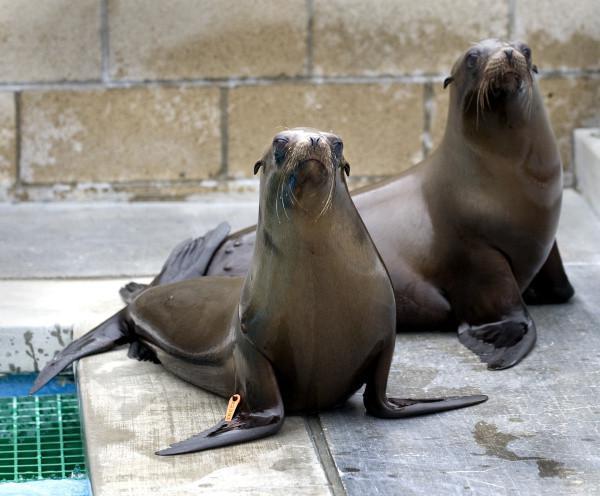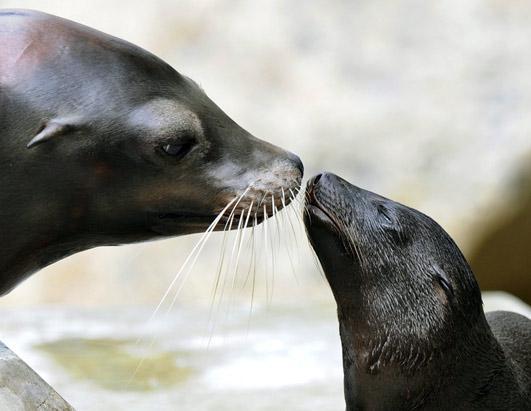The first image is the image on the left, the second image is the image on the right. Given the left and right images, does the statement "An adult seal to the right of a baby seal extends its neck to touch noses with the smaller animal." hold true? Answer yes or no. No. The first image is the image on the left, the second image is the image on the right. Evaluate the accuracy of this statement regarding the images: "The left and right images have the same amount of seals visible.". Is it true? Answer yes or no. Yes. 